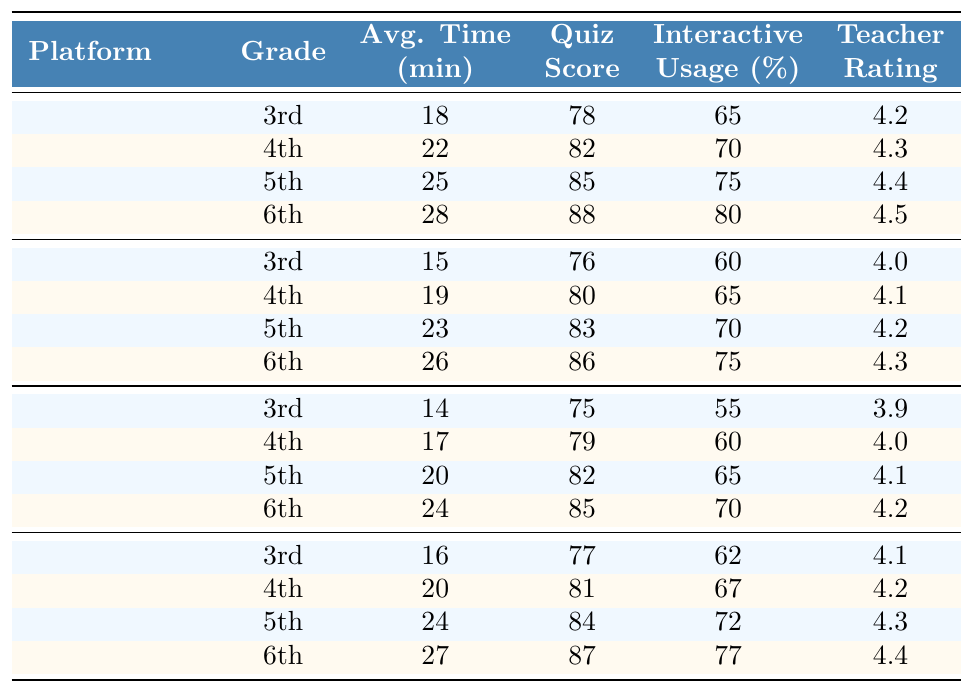What is the average time spent on Epic! for 6th graders? From the table, the average time spent on Epic! for 6th graders is listed as 28 minutes.
Answer: 28 minutes Which platform has the highest average quiz score for 5th graders? The table shows that Epic! has the highest average quiz score for 5th graders at 85.
Answer: Epic! What is the interactive feature usage percentage for 4th graders using ReadWorks? The table indicates that the interactive feature usage percentage for 4th graders using ReadWorks is 60%.
Answer: 60% Which grade level in Actively Learn shows the lowest average time spent? By comparing the average time spent across all grades in Actively Learn, the 3rd grade shows the lowest average time spent at 16 minutes.
Answer: 3rd grade True or False: The teacher satisfaction rating for Newsela 6th graders is higher than that for ReadWorks 5th graders. The teacher satisfaction rating for Newsela 6th graders is 4.3, and for ReadWorks 5th graders, it is 4.1. Thus, the statement is true.
Answer: True What is the average interactive feature usage percentage for all platforms at the 5th-grade level? The interactive feature usage percentages for 5th graders across all platforms are 75% (Epic!), 70% (Newsela), 65% (ReadWorks), and 72% (Actively Learn). The average is (75 + 70 + 65 + 72) / 4 = 70.5%.
Answer: 70.5% Which platform has the largest difference in average time spent between 3rd and 6th graders? For Epic!, the difference is 28 - 18 = 10 minutes. For Newsela, the difference is 26 - 15 = 11 minutes. For ReadWorks, it's 24 - 14 = 10 minutes. For Actively Learn, it's 27 - 16 = 11 minutes. So, Newsela and Actively Learn both have the largest difference of 11 minutes.
Answer: Newsela and Actively Learn Calculate the overall average teacher satisfaction rating across all platforms and grade levels. The teacher satisfaction ratings sum to 4.2 + 4.3 + 4.4 + 4.5 + 4.0 + 4.1 + 4.2 + 4.3 + 3.9 + 4.0 + 4.1 + 4.2 + 4.1 + 4.2 + 4.3 + 4.4 = 65.1. With 16 ratings, the average is 65.1 / 16 = 4.07.
Answer: 4.07 What is the average quiz score for 4th graders across all platforms? The quiz scores for 4th graders are 82 (Epic!), 80 (Newsela), 79 (ReadWorks), and 81 (Actively Learn). The total is 82 + 80 + 79 + 81 = 322. The average is 322 / 4 = 80.5.
Answer: 80.5 Which grade level among the different platforms shows the highest average interactive feature usage percentage? For 6th graders, the percentages are 80% (Epic!), 75% (Newsela), 70% (ReadWorks), and 77% (Actively Learn). Therefore, the highest is 80% for Epic!.
Answer: 80% 